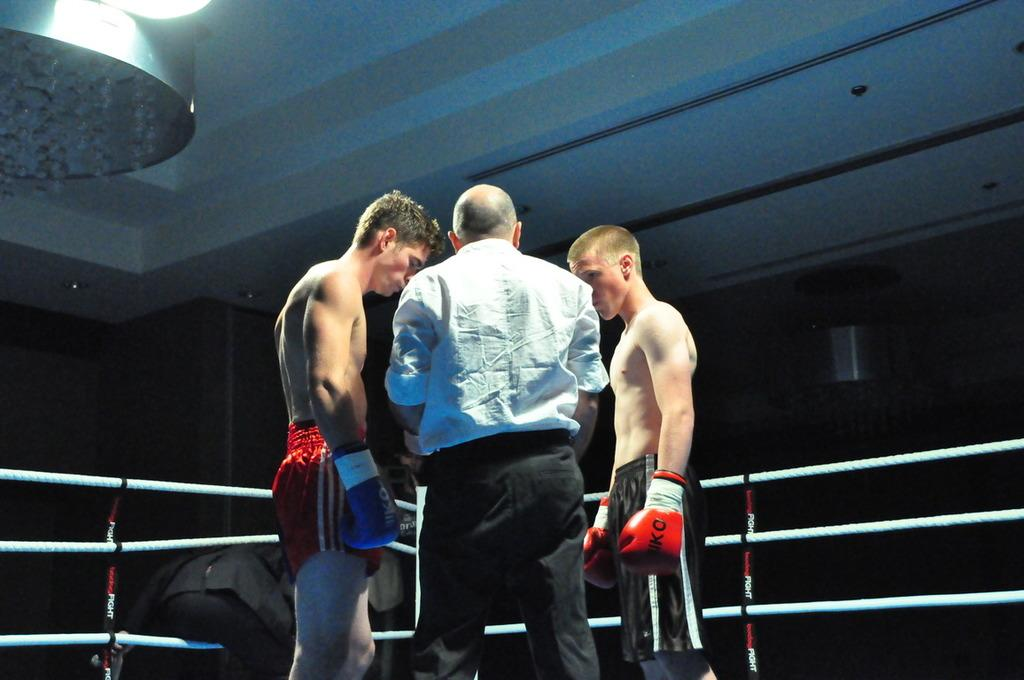How many people are in the image? There are people in the image, but the exact number is not specified. What are two of the people doing in the image? Two of the people are wearing boxing gloves, suggesting they might be engaged in a boxing activity. What can be seen in the image that might be used for a boxing ring? There are ropes in the image, which could be used to create a boxing ring. What type of lighting is present in the image? There are lights attached to the ceiling in the image, providing illumination for the scene. What type of cream is being applied to the laborer's hands in the image? There is no laborer or cream present in the image; it features people wearing boxing gloves and ropes that could be used for a boxing ring. 